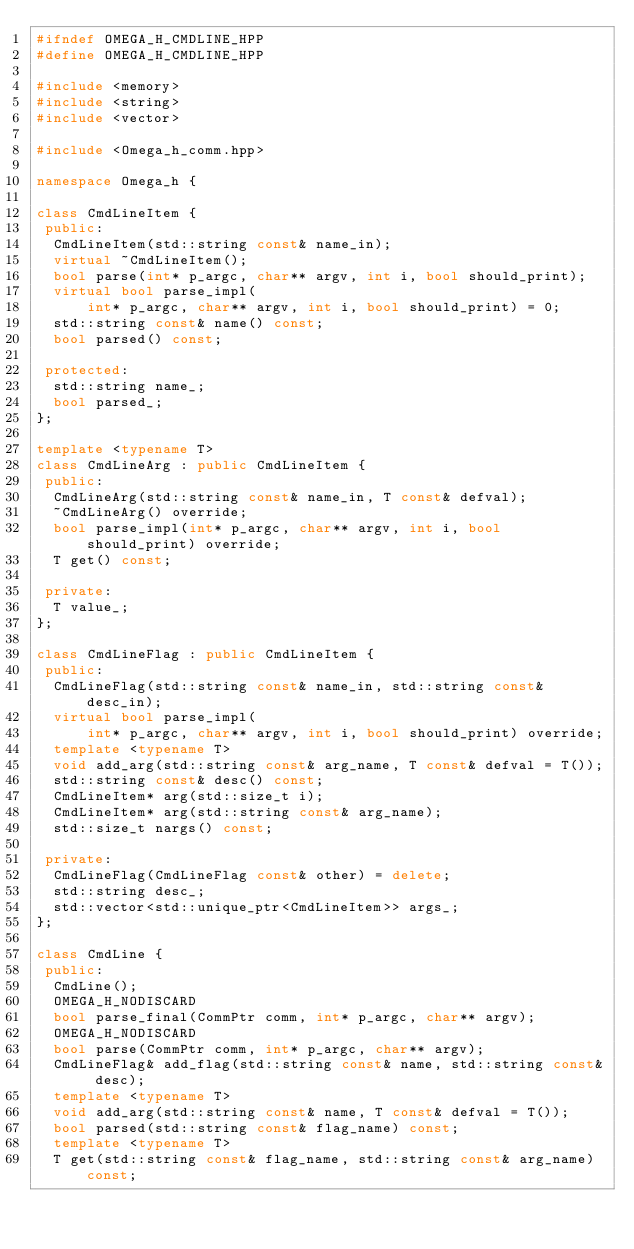<code> <loc_0><loc_0><loc_500><loc_500><_C++_>#ifndef OMEGA_H_CMDLINE_HPP
#define OMEGA_H_CMDLINE_HPP

#include <memory>
#include <string>
#include <vector>

#include <Omega_h_comm.hpp>

namespace Omega_h {

class CmdLineItem {
 public:
  CmdLineItem(std::string const& name_in);
  virtual ~CmdLineItem();
  bool parse(int* p_argc, char** argv, int i, bool should_print);
  virtual bool parse_impl(
      int* p_argc, char** argv, int i, bool should_print) = 0;
  std::string const& name() const;
  bool parsed() const;

 protected:
  std::string name_;
  bool parsed_;
};

template <typename T>
class CmdLineArg : public CmdLineItem {
 public:
  CmdLineArg(std::string const& name_in, T const& defval);
  ~CmdLineArg() override;
  bool parse_impl(int* p_argc, char** argv, int i, bool should_print) override;
  T get() const;

 private:
  T value_;
};

class CmdLineFlag : public CmdLineItem {
 public:
  CmdLineFlag(std::string const& name_in, std::string const& desc_in);
  virtual bool parse_impl(
      int* p_argc, char** argv, int i, bool should_print) override;
  template <typename T>
  void add_arg(std::string const& arg_name, T const& defval = T());
  std::string const& desc() const;
  CmdLineItem* arg(std::size_t i);
  CmdLineItem* arg(std::string const& arg_name);
  std::size_t nargs() const;

 private:
  CmdLineFlag(CmdLineFlag const& other) = delete;
  std::string desc_;
  std::vector<std::unique_ptr<CmdLineItem>> args_;
};

class CmdLine {
 public:
  CmdLine();
  OMEGA_H_NODISCARD
  bool parse_final(CommPtr comm, int* p_argc, char** argv);
  OMEGA_H_NODISCARD
  bool parse(CommPtr comm, int* p_argc, char** argv);
  CmdLineFlag& add_flag(std::string const& name, std::string const& desc);
  template <typename T>
  void add_arg(std::string const& name, T const& defval = T());
  bool parsed(std::string const& flag_name) const;
  template <typename T>
  T get(std::string const& flag_name, std::string const& arg_name) const;</code> 